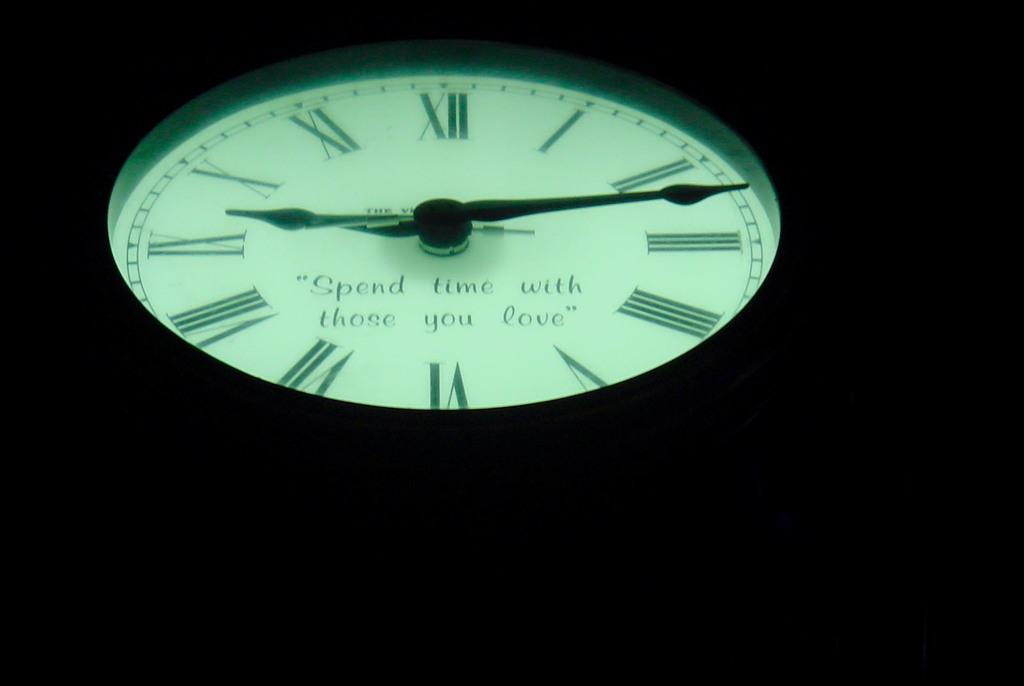<image>
Write a terse but informative summary of the picture. A glow in the dark clock face that says Spend time with those you love. 